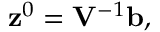Convert formula to latex. <formula><loc_0><loc_0><loc_500><loc_500>\begin{array} { r } { { z } ^ { 0 } = { V } ^ { - 1 } { b } , } \end{array}</formula> 